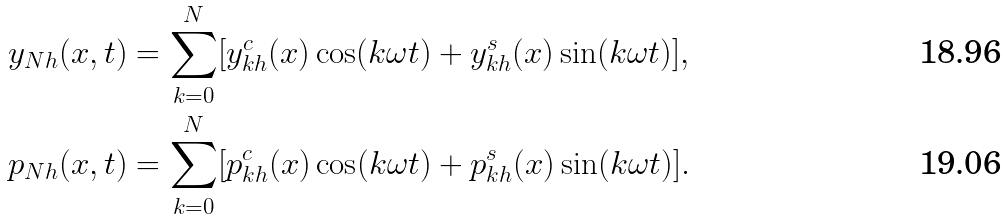<formula> <loc_0><loc_0><loc_500><loc_500>y _ { N h } ( x , t ) & = \sum _ { k = 0 } ^ { N } [ y _ { k h } ^ { c } ( x ) \cos ( k \omega t ) + y _ { k h } ^ { s } ( x ) \sin ( k \omega t ) ] , \\ p _ { N h } ( x , t ) & = \sum _ { k = 0 } ^ { N } [ p _ { k h } ^ { c } ( x ) \cos ( k \omega t ) + p _ { k h } ^ { s } ( x ) \sin ( k \omega t ) ] .</formula> 